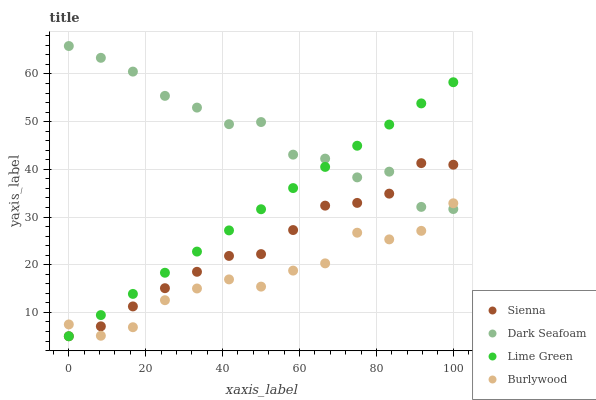Does Burlywood have the minimum area under the curve?
Answer yes or no. Yes. Does Dark Seafoam have the maximum area under the curve?
Answer yes or no. Yes. Does Dark Seafoam have the minimum area under the curve?
Answer yes or no. No. Does Burlywood have the maximum area under the curve?
Answer yes or no. No. Is Lime Green the smoothest?
Answer yes or no. Yes. Is Dark Seafoam the roughest?
Answer yes or no. Yes. Is Burlywood the smoothest?
Answer yes or no. No. Is Burlywood the roughest?
Answer yes or no. No. Does Sienna have the lowest value?
Answer yes or no. Yes. Does Burlywood have the lowest value?
Answer yes or no. No. Does Dark Seafoam have the highest value?
Answer yes or no. Yes. Does Burlywood have the highest value?
Answer yes or no. No. Does Burlywood intersect Dark Seafoam?
Answer yes or no. Yes. Is Burlywood less than Dark Seafoam?
Answer yes or no. No. Is Burlywood greater than Dark Seafoam?
Answer yes or no. No. 